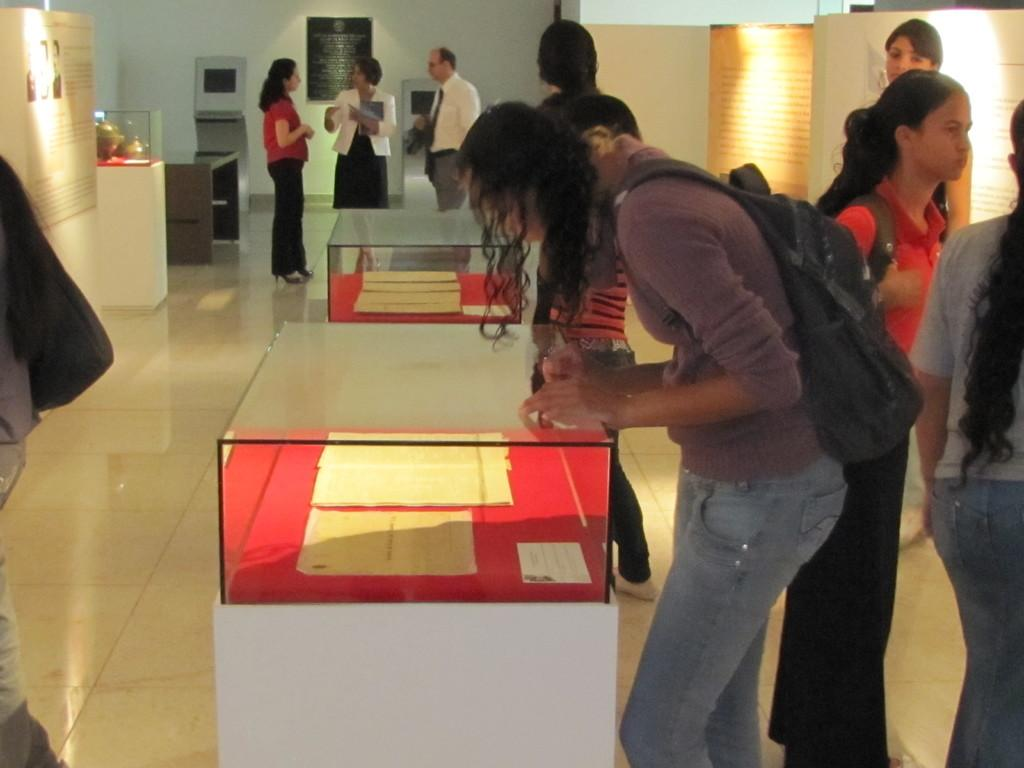How many people are in the image? There is a group of people standing in the image. What is the surface the people are standing on? The people are standing on the floor. What objects can be seen in the image besides the people? There are glass boxes and banners present in the image. What can be seen in the background of the image? There is a wall in the background of the image. What type of noise is being made by the cattle in the image? There are no cattle present in the image, so no noise can be attributed to them. 